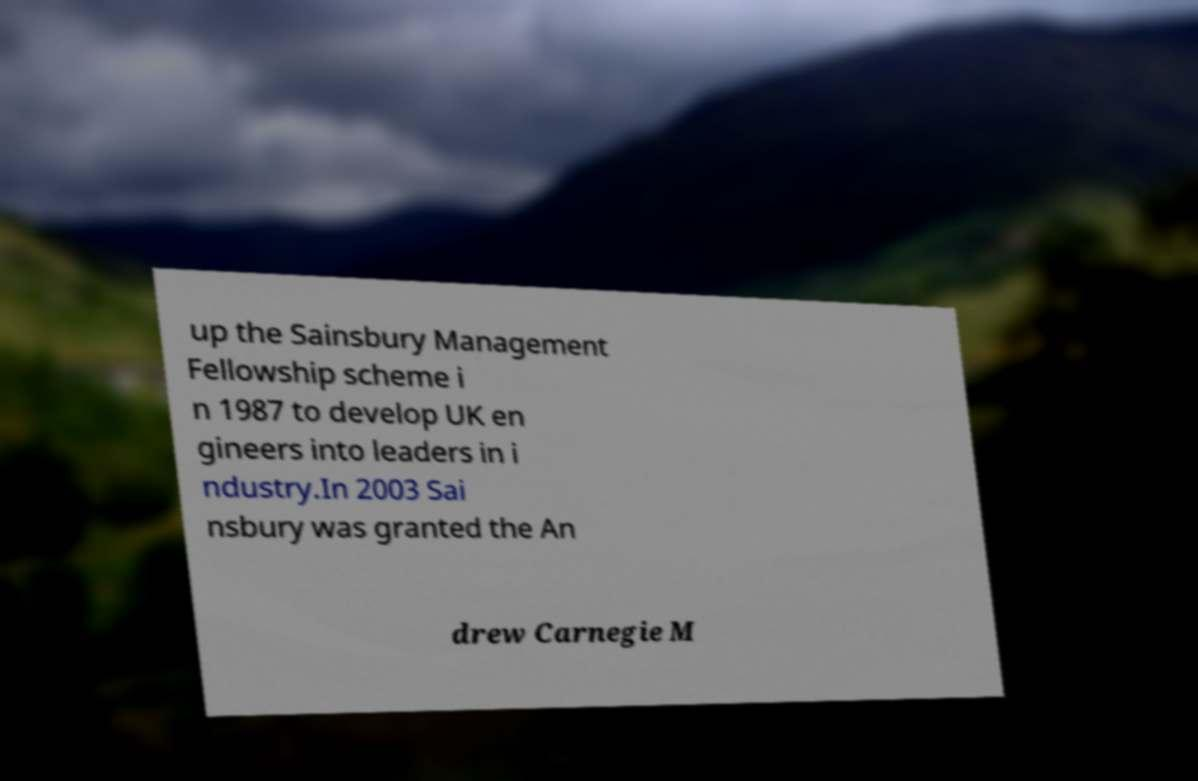Could you assist in decoding the text presented in this image and type it out clearly? up the Sainsbury Management Fellowship scheme i n 1987 to develop UK en gineers into leaders in i ndustry.In 2003 Sai nsbury was granted the An drew Carnegie M 